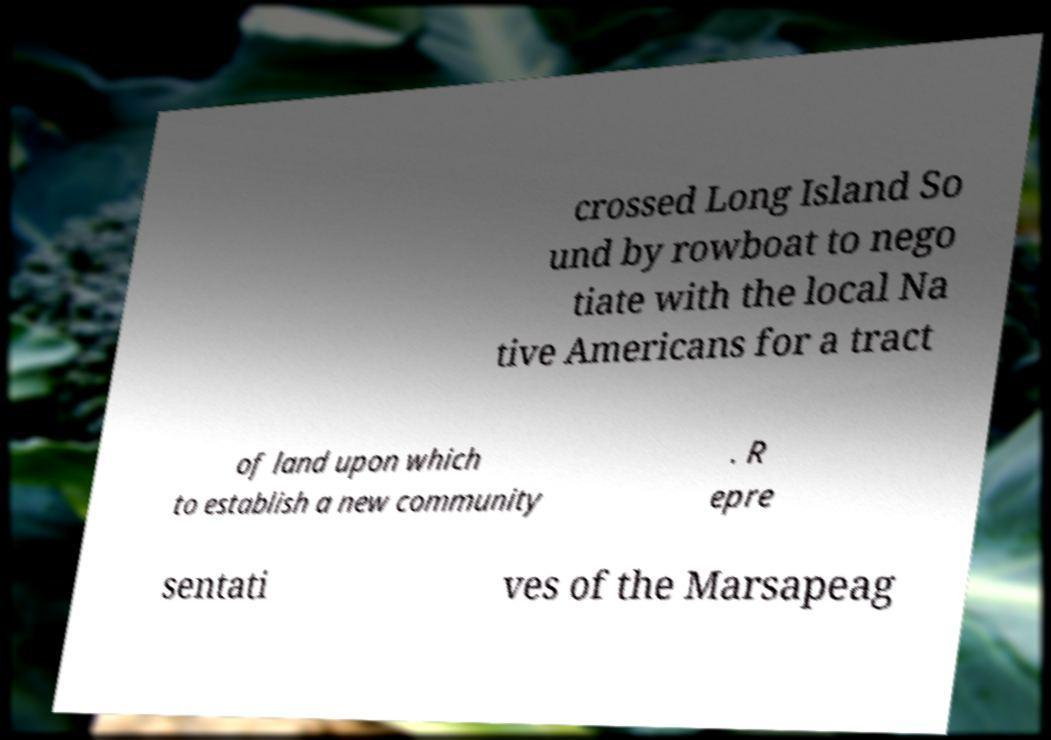There's text embedded in this image that I need extracted. Can you transcribe it verbatim? crossed Long Island So und by rowboat to nego tiate with the local Na tive Americans for a tract of land upon which to establish a new community . R epre sentati ves of the Marsapeag 